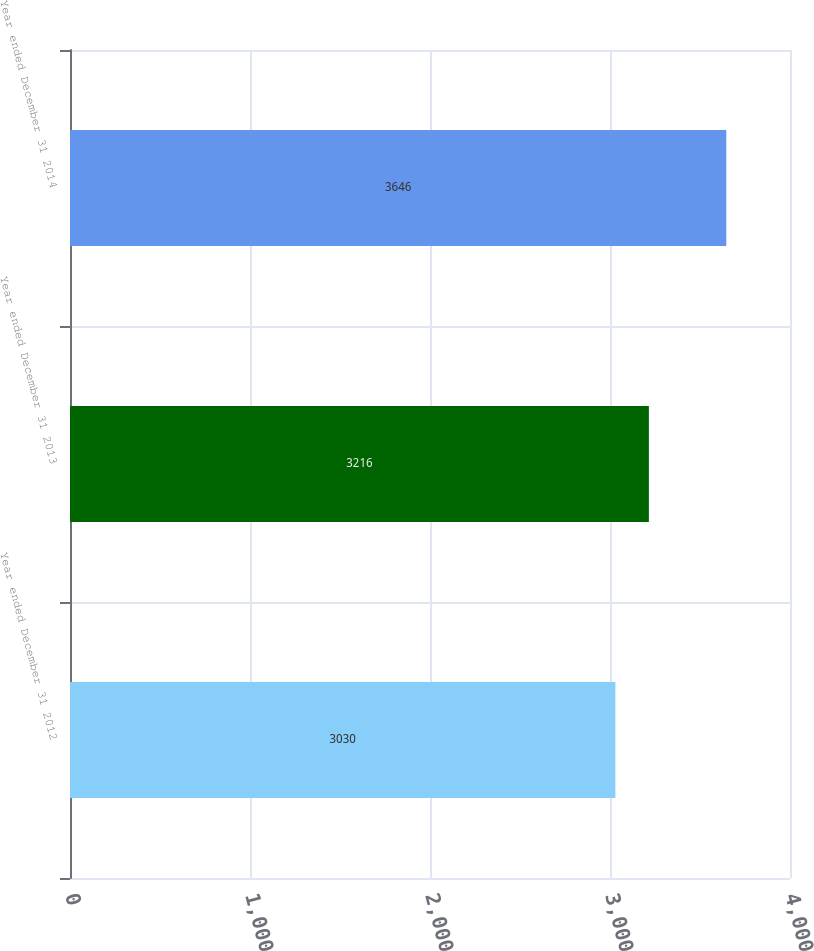Convert chart. <chart><loc_0><loc_0><loc_500><loc_500><bar_chart><fcel>Year ended December 31 2012<fcel>Year ended December 31 2013<fcel>Year ended December 31 2014<nl><fcel>3030<fcel>3216<fcel>3646<nl></chart> 